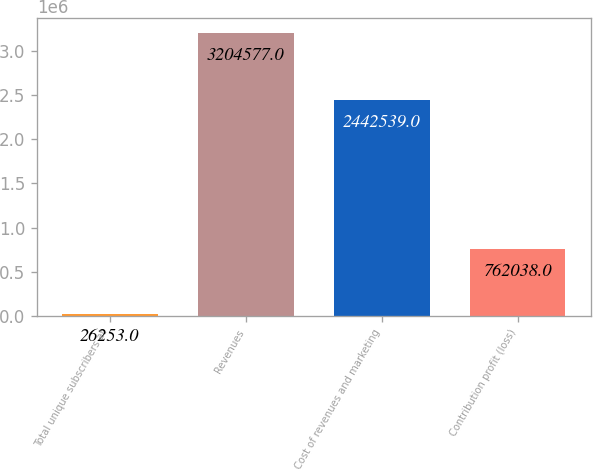<chart> <loc_0><loc_0><loc_500><loc_500><bar_chart><fcel>Total unique subscribers at<fcel>Revenues<fcel>Cost of revenues and marketing<fcel>Contribution profit (loss)<nl><fcel>26253<fcel>3.20458e+06<fcel>2.44254e+06<fcel>762038<nl></chart> 